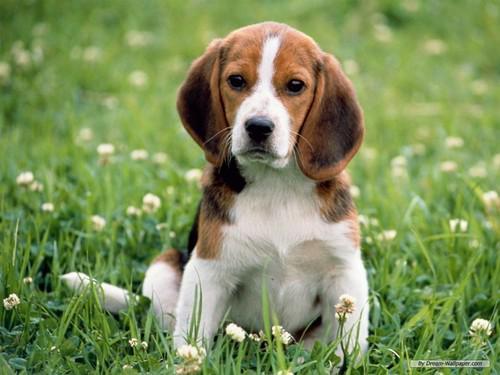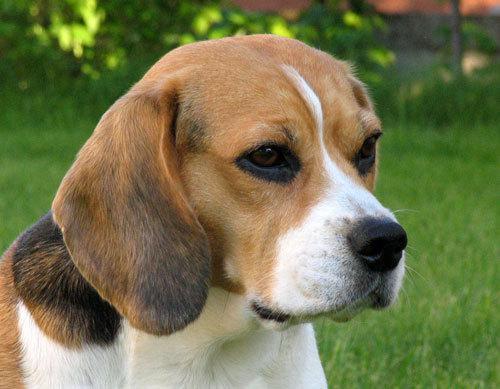The first image is the image on the left, the second image is the image on the right. For the images displayed, is the sentence "At least one dog wears something around his neck." factually correct? Answer yes or no. No. 